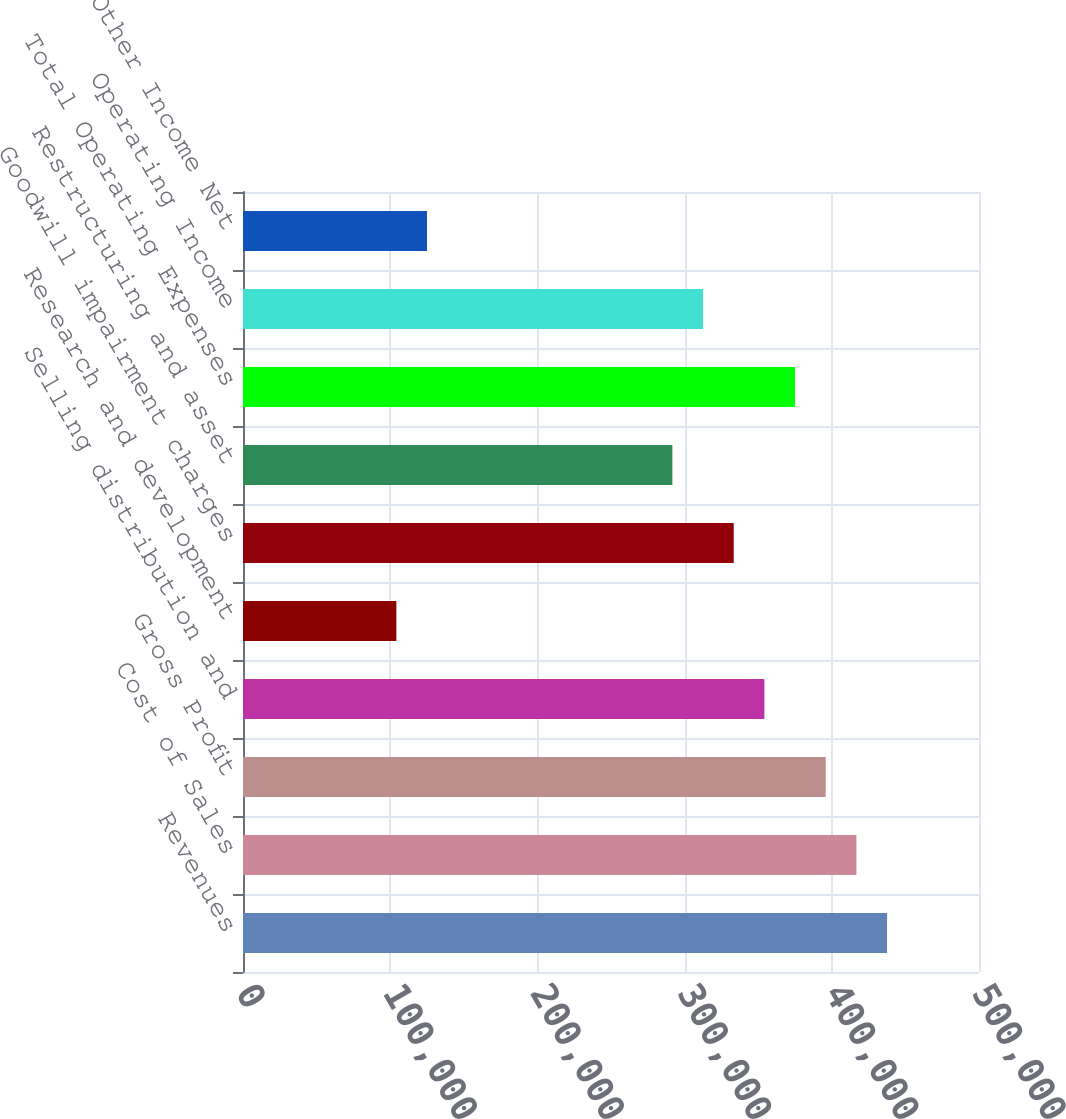Convert chart to OTSL. <chart><loc_0><loc_0><loc_500><loc_500><bar_chart><fcel>Revenues<fcel>Cost of Sales<fcel>Gross Profit<fcel>Selling distribution and<fcel>Research and development<fcel>Goodwill impairment charges<fcel>Restructuring and asset<fcel>Total Operating Expenses<fcel>Operating Income<fcel>Other Income Net<nl><fcel>437549<fcel>416714<fcel>395878<fcel>354207<fcel>104179<fcel>333371<fcel>291700<fcel>375042<fcel>312535<fcel>125014<nl></chart> 